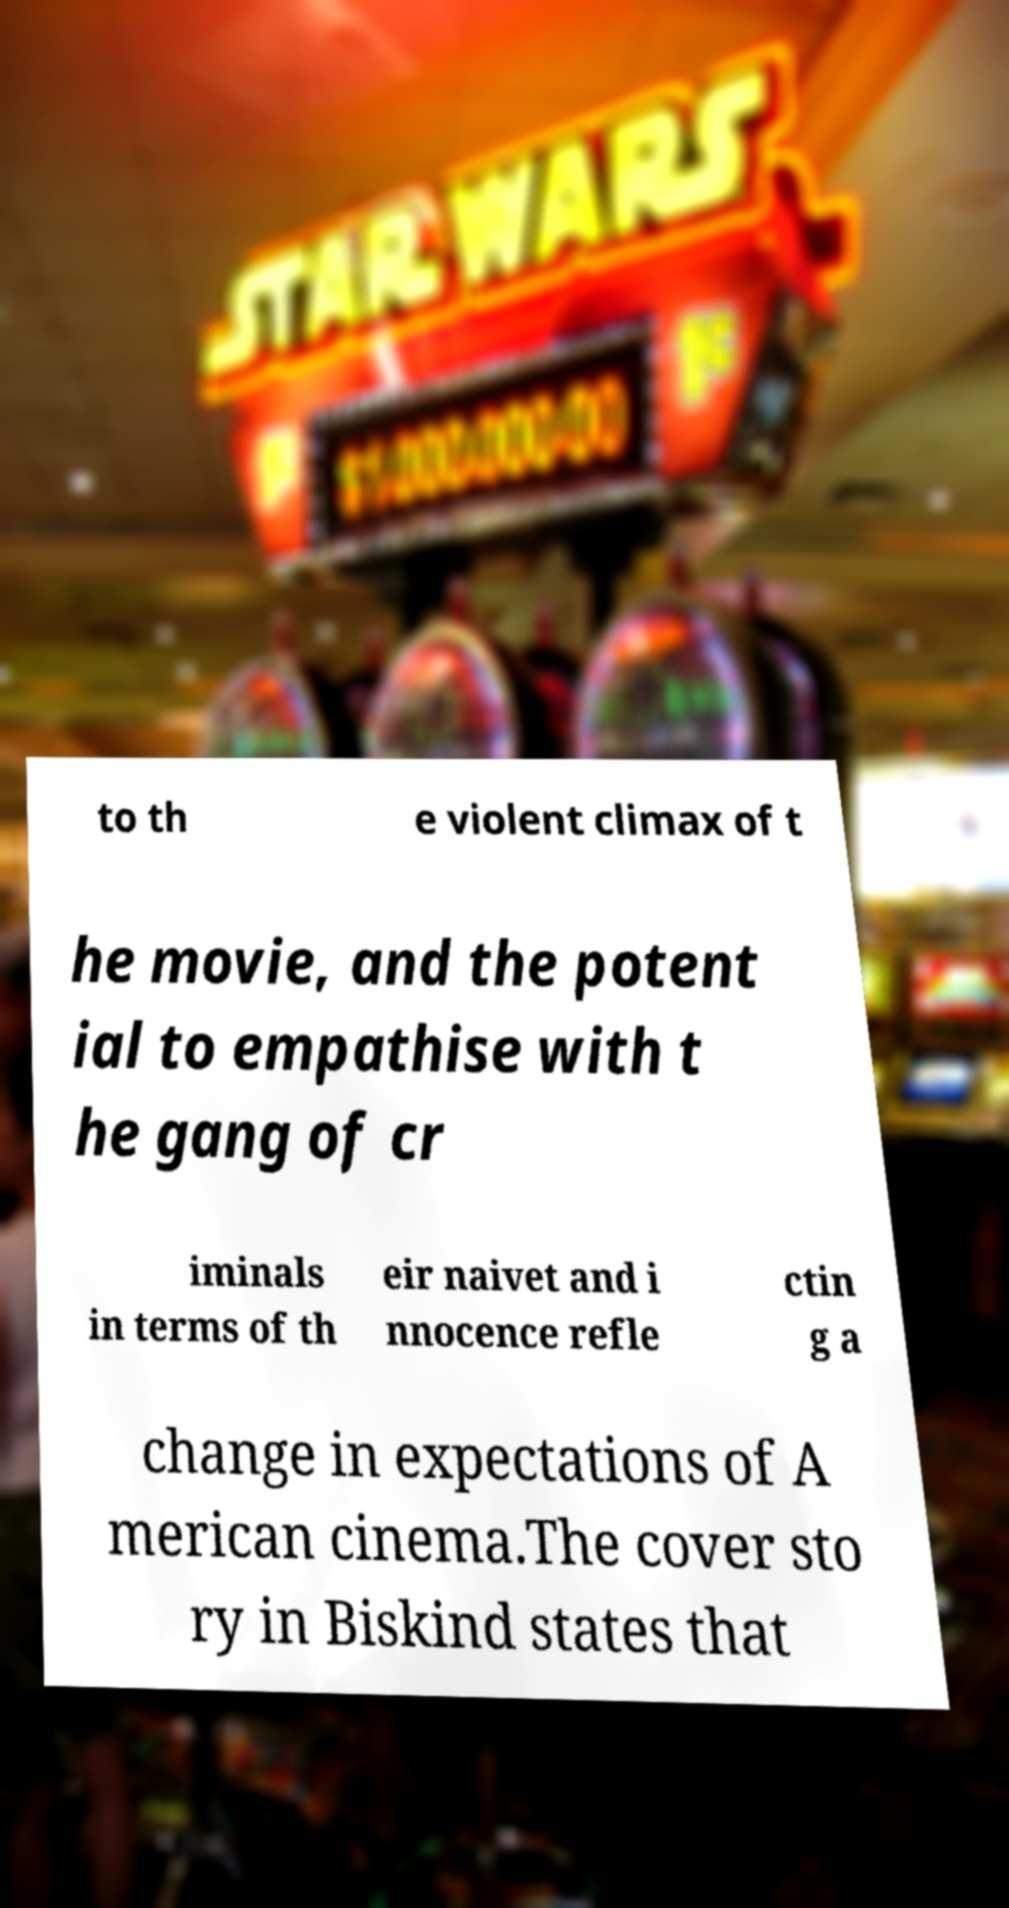I need the written content from this picture converted into text. Can you do that? to th e violent climax of t he movie, and the potent ial to empathise with t he gang of cr iminals in terms of th eir naivet and i nnocence refle ctin g a change in expectations of A merican cinema.The cover sto ry in Biskind states that 